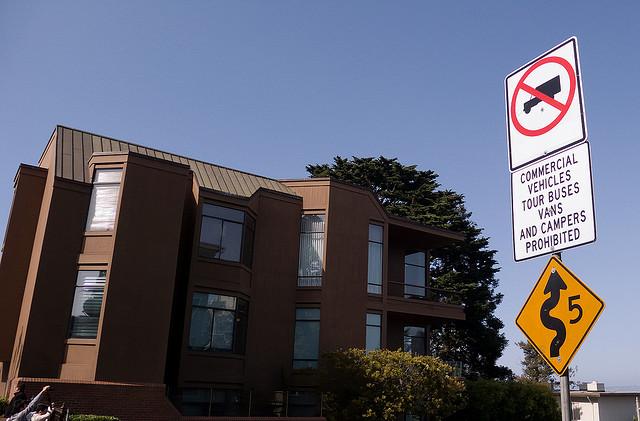Are commercial vehicles allowed on this street?
Give a very brief answer. No. Is there a skyscraper?
Concise answer only. No. Is the sky blue?
Concise answer only. Yes. Is the tree taller than the building?
Be succinct. Yes. What does the number 5 mean?
Concise answer only. Speed. Are there clouds in the photo?
Write a very short answer. No. What type of road is advertised?
Give a very brief answer. Curvy. 